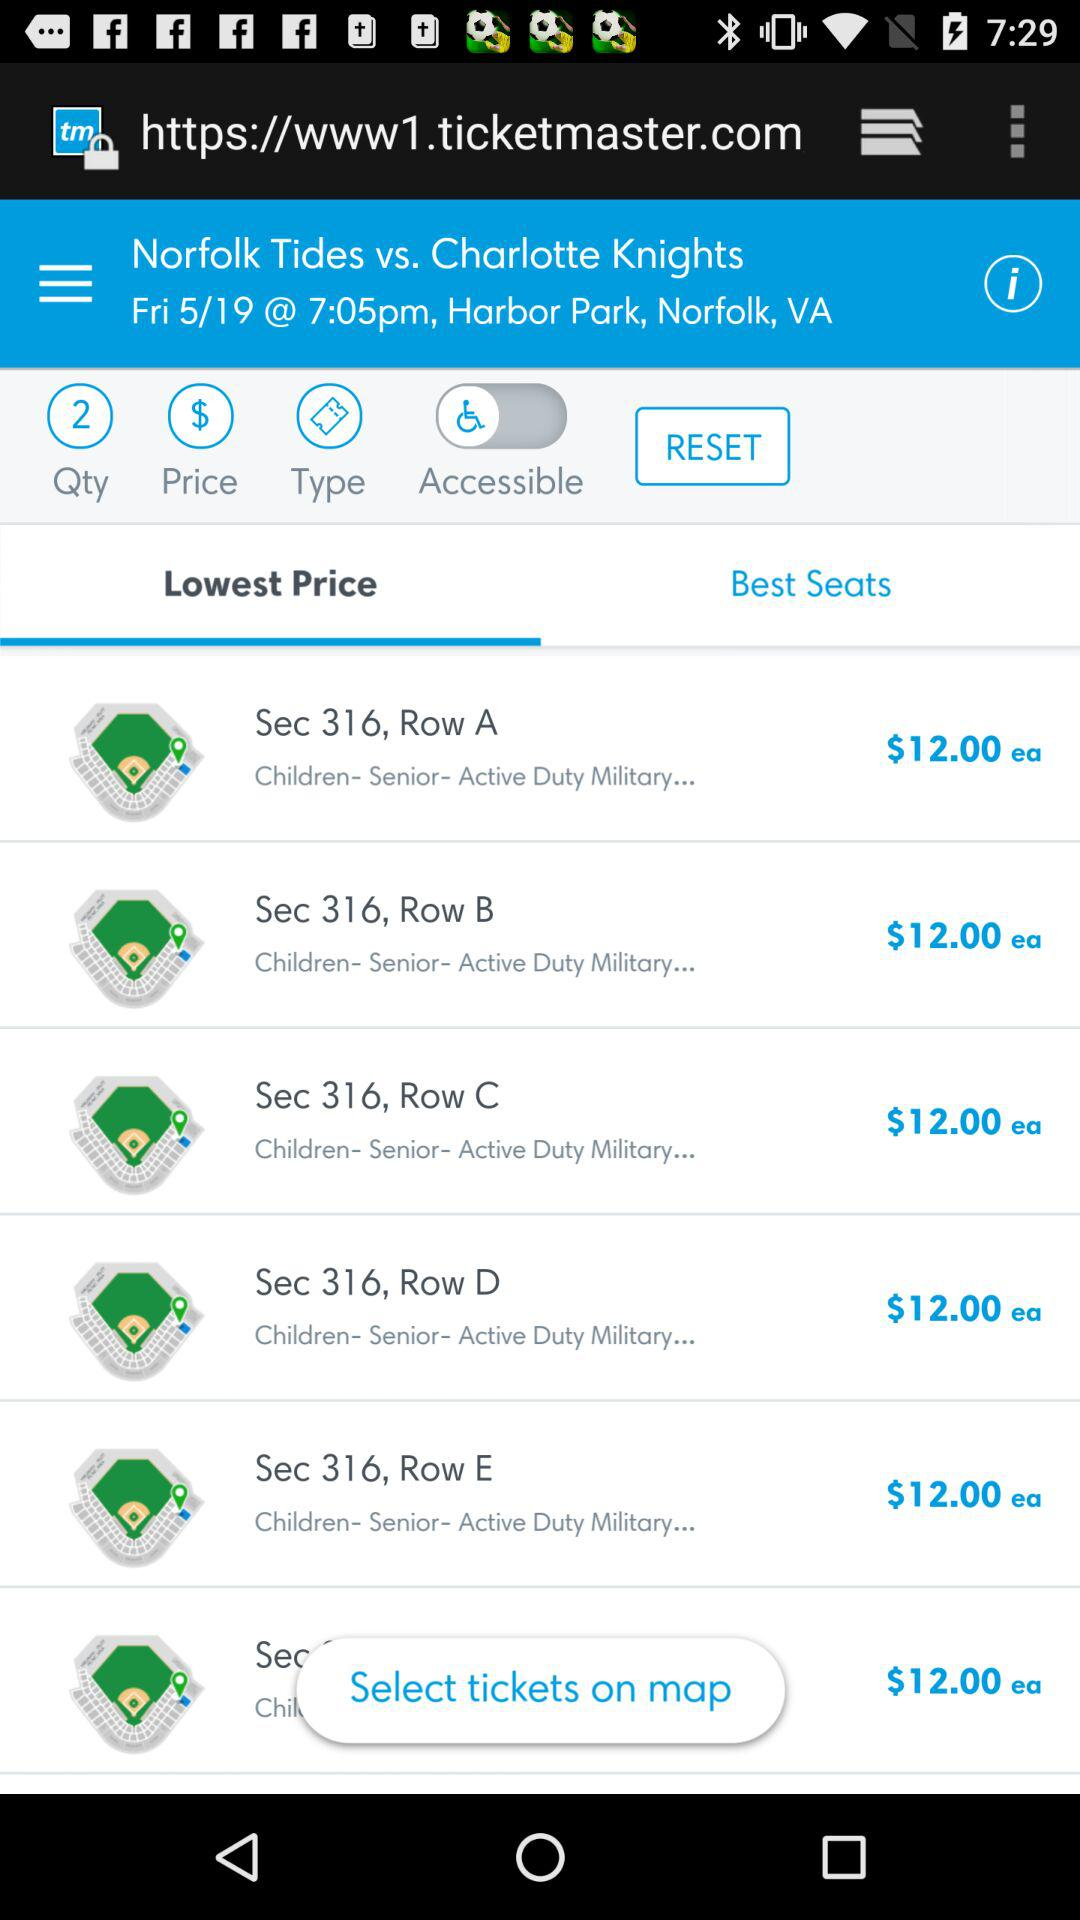How many sections are available for selection?
Answer the question using a single word or phrase. 6 